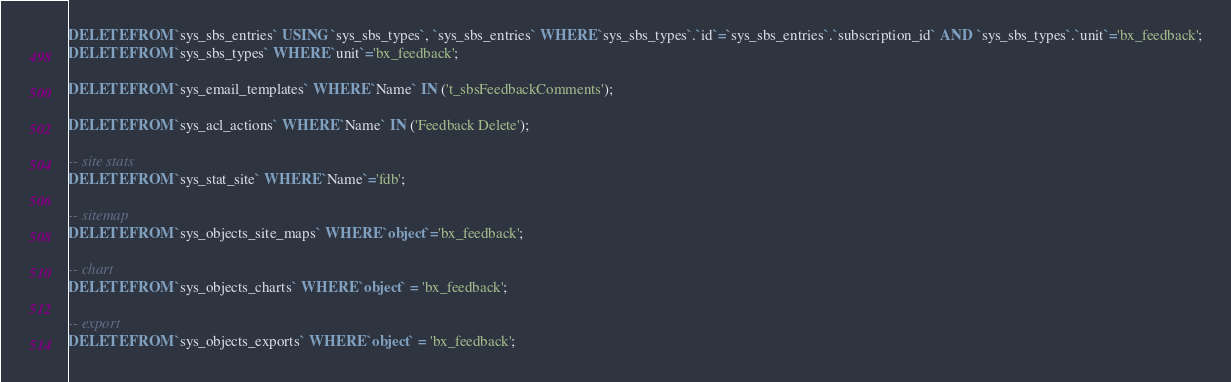Convert code to text. <code><loc_0><loc_0><loc_500><loc_500><_SQL_>DELETE FROM `sys_sbs_entries` USING `sys_sbs_types`, `sys_sbs_entries` WHERE `sys_sbs_types`.`id`=`sys_sbs_entries`.`subscription_id` AND `sys_sbs_types`.`unit`='bx_feedback';
DELETE FROM `sys_sbs_types` WHERE `unit`='bx_feedback';

DELETE FROM `sys_email_templates` WHERE `Name` IN ('t_sbsFeedbackComments');

DELETE FROM `sys_acl_actions` WHERE `Name` IN ('Feedback Delete');

-- site stats
DELETE FROM `sys_stat_site` WHERE `Name`='fdb';

-- sitemap
DELETE FROM `sys_objects_site_maps` WHERE `object`='bx_feedback';

-- chart
DELETE FROM `sys_objects_charts` WHERE `object` = 'bx_feedback';

-- export
DELETE FROM `sys_objects_exports` WHERE `object` = 'bx_feedback';
</code> 